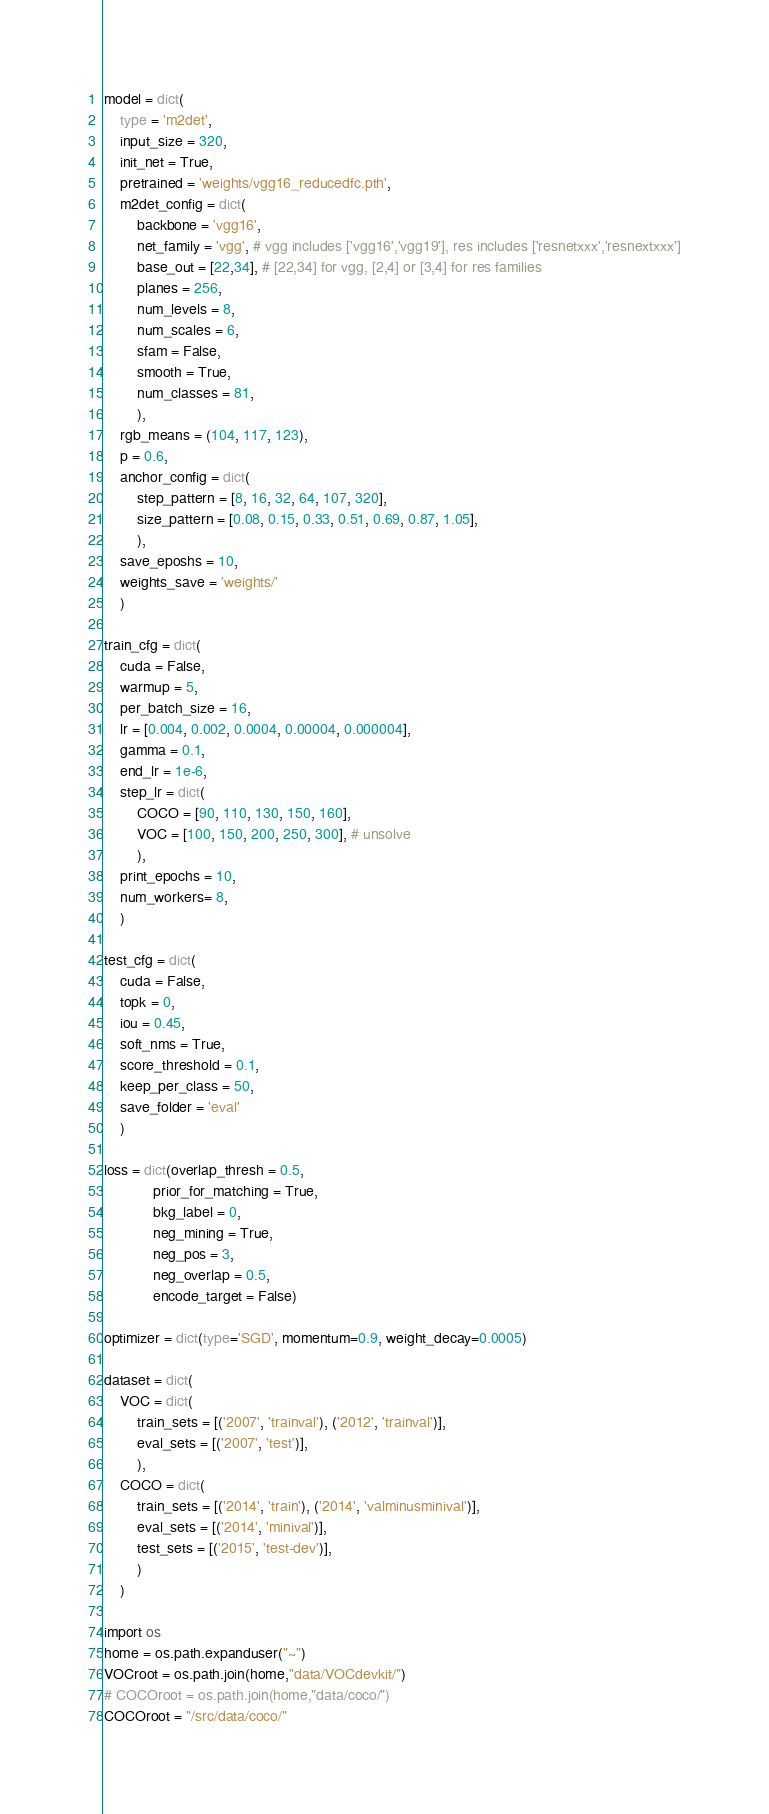Convert code to text. <code><loc_0><loc_0><loc_500><loc_500><_Python_>model = dict(
    type = 'm2det',
    input_size = 320,
    init_net = True,
    pretrained = 'weights/vgg16_reducedfc.pth',
    m2det_config = dict(
        backbone = 'vgg16',
        net_family = 'vgg', # vgg includes ['vgg16','vgg19'], res includes ['resnetxxx','resnextxxx']
        base_out = [22,34], # [22,34] for vgg, [2,4] or [3,4] for res families
        planes = 256,
        num_levels = 8,
        num_scales = 6,
        sfam = False,
        smooth = True,
        num_classes = 81,
        ),
    rgb_means = (104, 117, 123),
    p = 0.6,
    anchor_config = dict(
        step_pattern = [8, 16, 32, 64, 107, 320],
        size_pattern = [0.08, 0.15, 0.33, 0.51, 0.69, 0.87, 1.05],
        ),
    save_eposhs = 10,
    weights_save = 'weights/'
    )

train_cfg = dict(
    cuda = False,
    warmup = 5,
    per_batch_size = 16,
    lr = [0.004, 0.002, 0.0004, 0.00004, 0.000004],
    gamma = 0.1,
    end_lr = 1e-6,
    step_lr = dict(
        COCO = [90, 110, 130, 150, 160],
        VOC = [100, 150, 200, 250, 300], # unsolve
        ),
    print_epochs = 10,
    num_workers= 8,
    )

test_cfg = dict(
    cuda = False,
    topk = 0,
    iou = 0.45,
    soft_nms = True,
    score_threshold = 0.1,
    keep_per_class = 50,
    save_folder = 'eval'
    )

loss = dict(overlap_thresh = 0.5,
            prior_for_matching = True,
            bkg_label = 0,
            neg_mining = True,
            neg_pos = 3,
            neg_overlap = 0.5,
            encode_target = False)

optimizer = dict(type='SGD', momentum=0.9, weight_decay=0.0005)

dataset = dict(
    VOC = dict(
        train_sets = [('2007', 'trainval'), ('2012', 'trainval')],
        eval_sets = [('2007', 'test')],
        ),
    COCO = dict(
        train_sets = [('2014', 'train'), ('2014', 'valminusminival')],
        eval_sets = [('2014', 'minival')],
        test_sets = [('2015', 'test-dev')],
        )
    )

import os
home = os.path.expanduser("~")
VOCroot = os.path.join(home,"data/VOCdevkit/")
# COCOroot = os.path.join(home,"data/coco/")
COCOroot = "/src/data/coco/"
</code> 